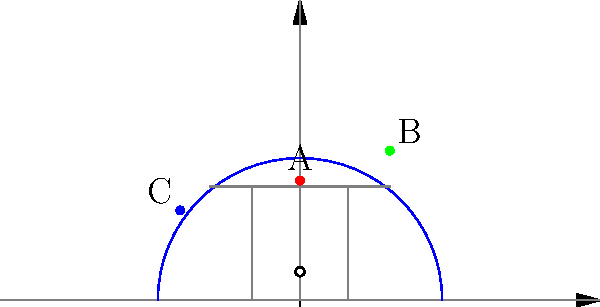Based on the basketball court diagram showing three shot locations (A, B, and C), which shot is likely to have the highest accuracy for a player like Valerie Nainima, known for her mid-range game? To determine which shot is likely to have the highest accuracy, we need to consider the following factors:

1. Shot distance: Generally, shots closer to the basket have higher accuracy.
2. Shot angle: Shots taken from a straight-on angle tend to be more accurate than angled shots.
3. Player's strengths: Valerie Nainima was known for her mid-range game.

Let's analyze each shot:

A. Located at (0, 20), this is a straight-on mid-range shot from the free-throw line extended.
   Distance: Approximately 20 feet
   Angle: 0 degrees (straight-on)

B. Located at (15, 25), this is an angled three-point shot.
   Distance: Approximately 29 feet
   Angle: About 31 degrees from the center

C. Located at (-20, 15), this is an angled mid-range shot.
   Distance: Approximately 25 feet
   Angle: About 53 degrees from the center

Considering Valerie Nainima's strength in the mid-range game, we can eliminate shot B as it's a three-point shot and likely not her highest percentage shot.

Between A and C, both are mid-range shots, but A has two advantages:
1. It's closer to the basket (20 feet vs 25 feet).
2. It's a straight-on shot, which is generally easier than angled shots.

Therefore, shot A is likely to have the highest accuracy for a player like Valerie Nainima.
Answer: A 